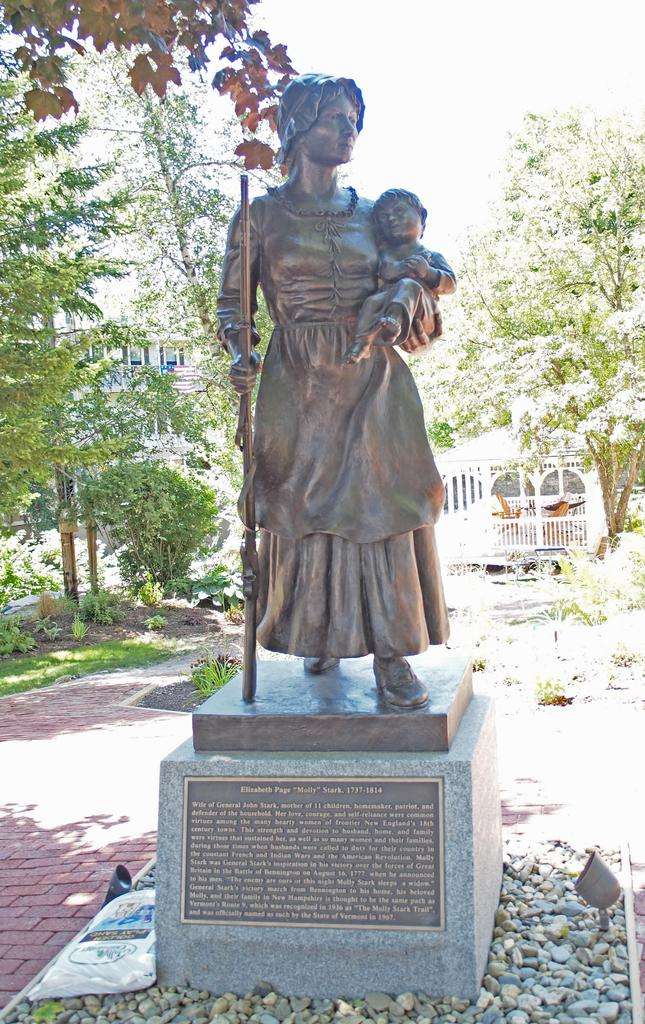What is the main subject in the center of the image? There is a statue in the center of the image. How is the statue positioned in the image? The statue is on a pedestal. What can be seen at the bottom of the image? There are stones at the bottom of the image. What is visible in the background of the image? There are trees, buildings, and the sky visible in the background of the image. What type of hair can be seen on the squirrel in the image? There is no squirrel present in the image; it features a statue on a pedestal. What news event is being reported by the statue in the image? The statue is not reporting any news event; it is a stationary object in the image. 